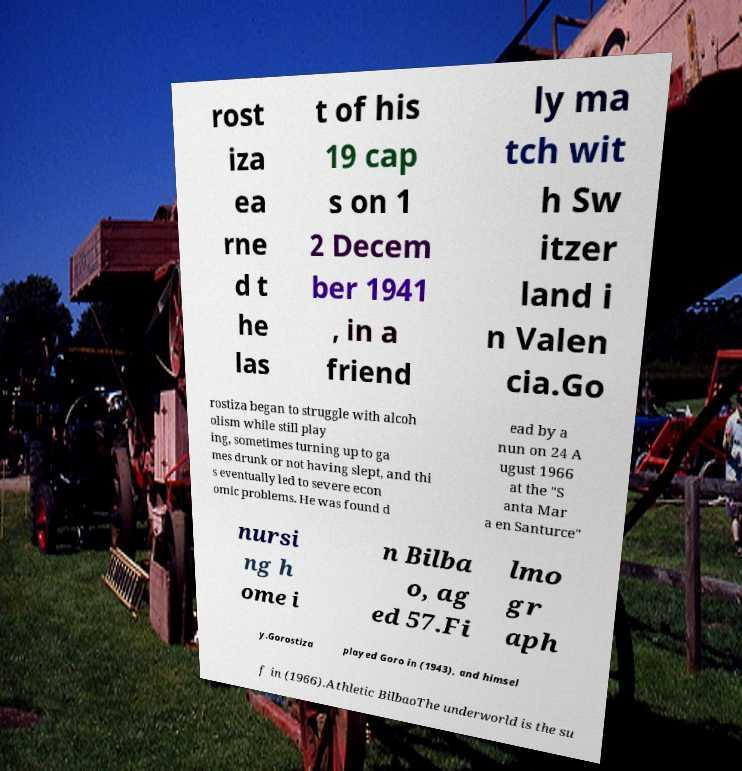I need the written content from this picture converted into text. Can you do that? rost iza ea rne d t he las t of his 19 cap s on 1 2 Decem ber 1941 , in a friend ly ma tch wit h Sw itzer land i n Valen cia.Go rostiza began to struggle with alcoh olism while still play ing, sometimes turning up to ga mes drunk or not having slept, and thi s eventually led to severe econ omic problems. He was found d ead by a nun on 24 A ugust 1966 at the "S anta Mar a en Santurce" nursi ng h ome i n Bilba o, ag ed 57.Fi lmo gr aph y.Gorostiza played Goro in (1943), and himsel f in (1966).Athletic BilbaoThe underworld is the su 